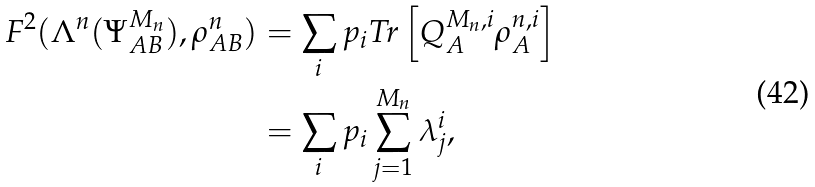Convert formula to latex. <formula><loc_0><loc_0><loc_500><loc_500>F ^ { 2 } ( \Lambda ^ { n } ( \Psi ^ { M _ { n } } _ { A B } ) , \rho ^ { n } _ { A B } ) & = \sum _ { i } p _ { i } T r \left [ Q ^ { M _ { n } , i } _ { A } \rho ^ { n , i } _ { A } \right ] \\ & = \sum _ { i } p _ { i } \sum _ { j = 1 } ^ { M _ { n } } \lambda _ { j } ^ { i } ,</formula> 